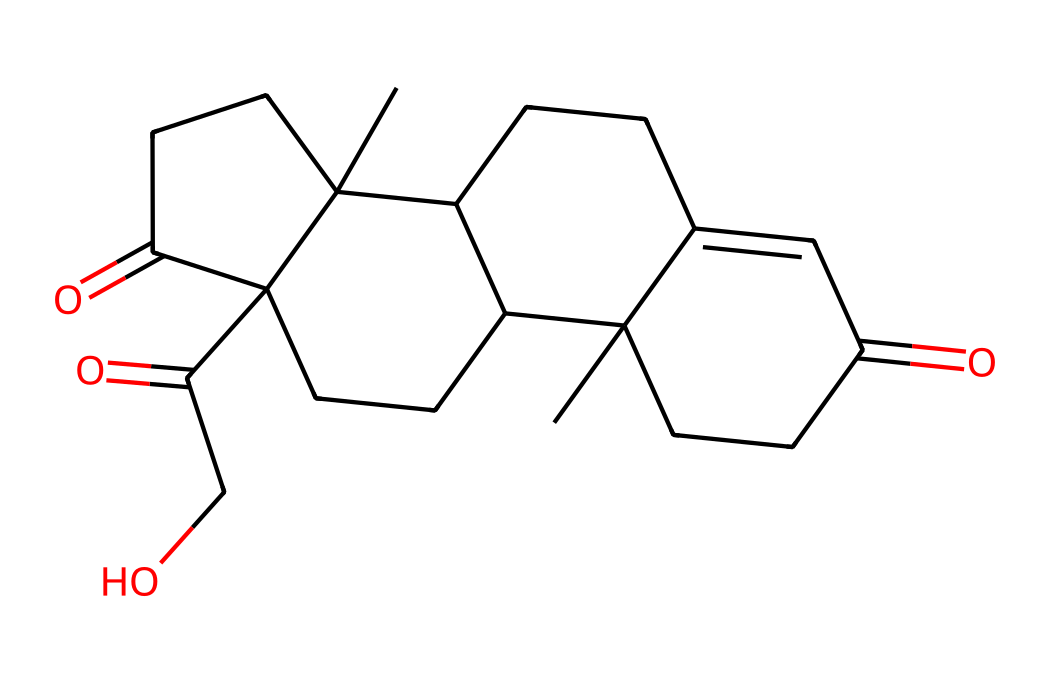What is the molecular formula of cortisol? To determine the molecular formula, we count the number of each type of atom in the structure represented by the SMILES notation. The structure indicates the presence of carbon (C), hydrogen (H), and oxygen (O) atoms. After analyzing the SMILES, we find 21 carbons, 30 hydrogens, and 5 oxygens, leading to the formula C21H30O5.
Answer: C21H30O5 How many rings are present in the cortisol structure? By examining the SMILES notation, we can identify the ring structures. The digits in the SMILES indicate the starting and ending points of rings. Counting these, we find there are four distinct rings in the structure of cortisol.
Answer: 4 What type of lipid is cortisol classified as? Cortisol is best classified as a steroid hormone, which is a specific type of lipid characterized by a fused ring structure. The presence of multiple cycloalkane rings in the structure confirms its steroid classification.
Answer: steroid What is the primary function of cortisol in the body? Cortisol primarily functions to regulate metabolism, immune response, and stress response. It plays a critical role in helping the body manage stress by increasing glucose levels and aiding in metabolism.
Answer: stress regulation What functional groups are present in cortisol? Analyzing the structure, we can find carbonyl (C=O) and hydroxyl (–OH) functional groups. The presence of these groups indicates that cortisol has specific properties such as solubility and reactivity associated with these functional groups.
Answer: carbonyl and hydroxyl What property does cortisol exhibit due to its lipid structure? Being a lipid (and specifically a steroid), cortisol is hydrophobic, which means it can easily cross cell membranes. This characteristic is fundamental to its role as a hormone, allowing it to interact with target cells effectively.
Answer: hydrophobic 